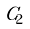<formula> <loc_0><loc_0><loc_500><loc_500>\tilde { C } _ { 2 }</formula> 